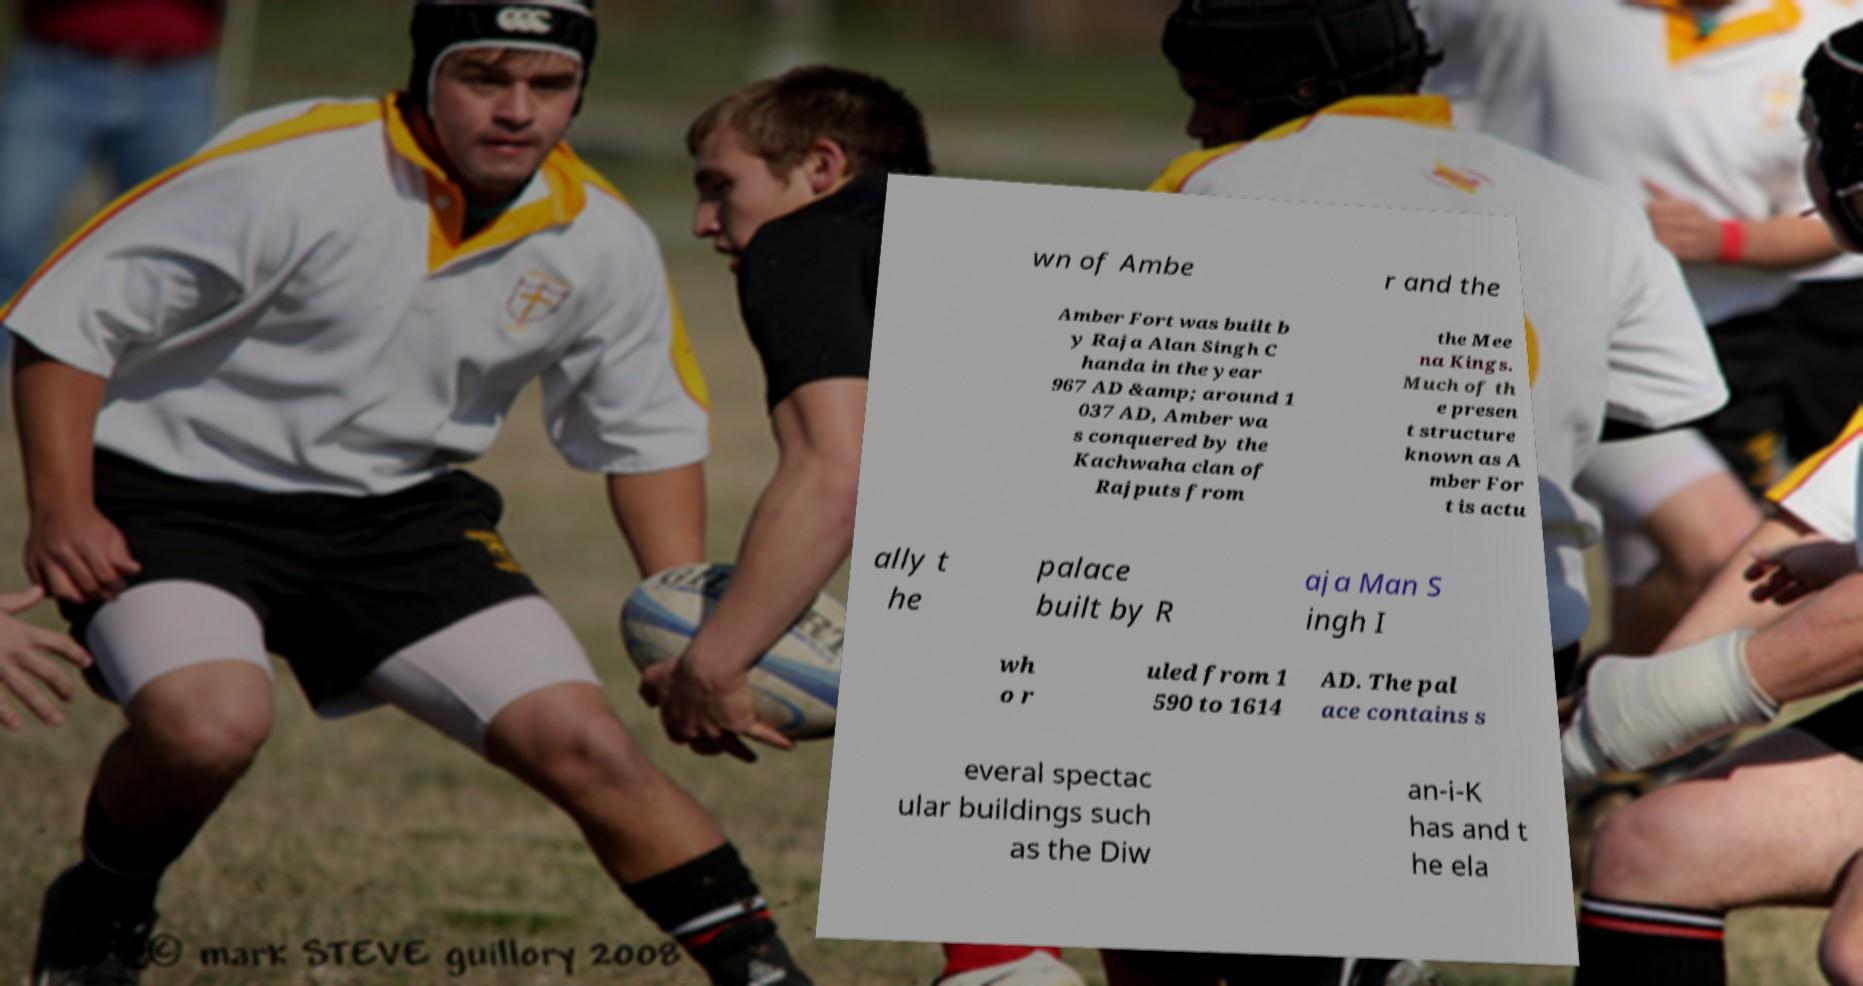Could you extract and type out the text from this image? wn of Ambe r and the Amber Fort was built b y Raja Alan Singh C handa in the year 967 AD &amp; around 1 037 AD, Amber wa s conquered by the Kachwaha clan of Rajputs from the Mee na Kings. Much of th e presen t structure known as A mber For t is actu ally t he palace built by R aja Man S ingh I wh o r uled from 1 590 to 1614 AD. The pal ace contains s everal spectac ular buildings such as the Diw an-i-K has and t he ela 